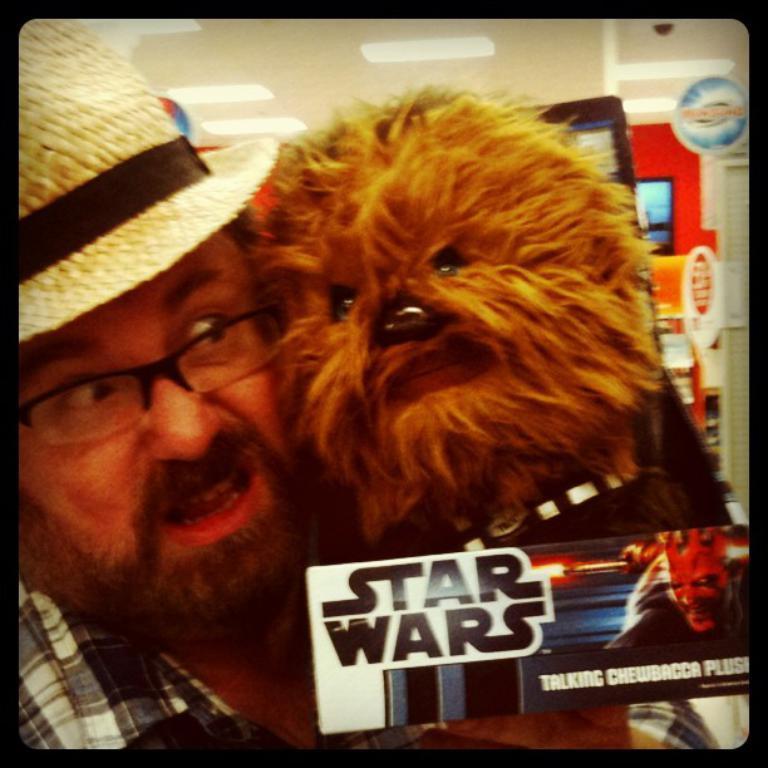Could you give a brief overview of what you see in this image? In this image we can a man and a dog, man is wearing hat and shirt. Right bottom of the image one sticker is there with some text written on it. 